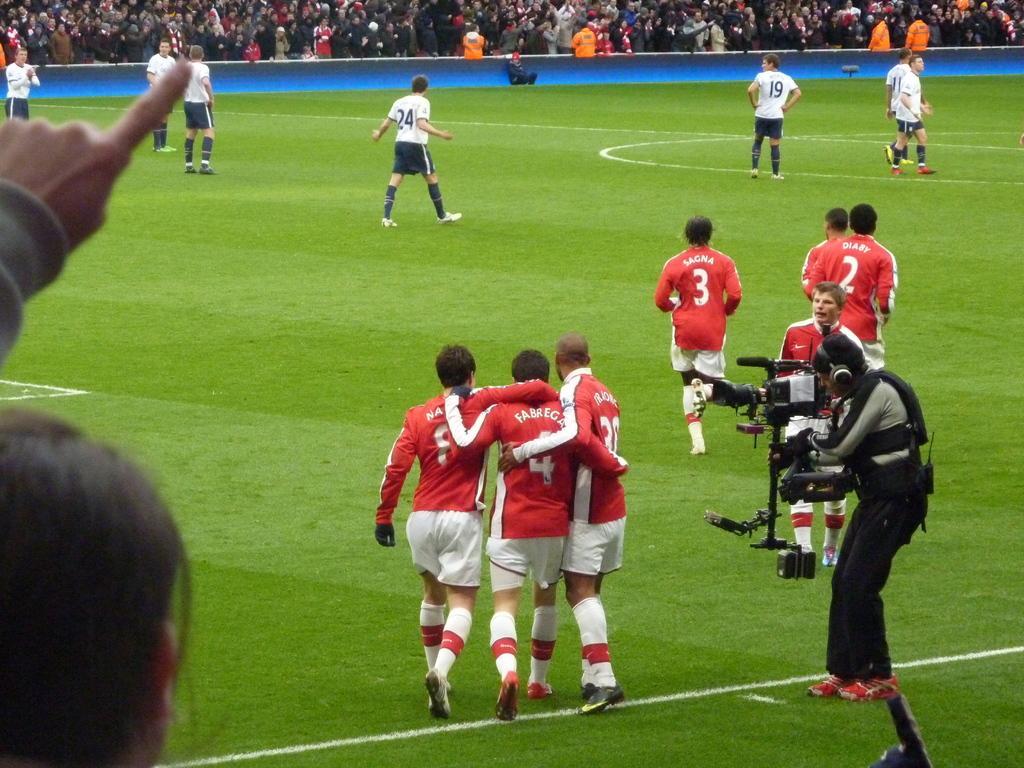Can you describe this image briefly? In this image we can see a group of people standing on the ground. On the right side of the image we can see a person wearing headphones and holding a camera in his hand. In the foreground we can see a woman. In the background, we can see group of audience. 